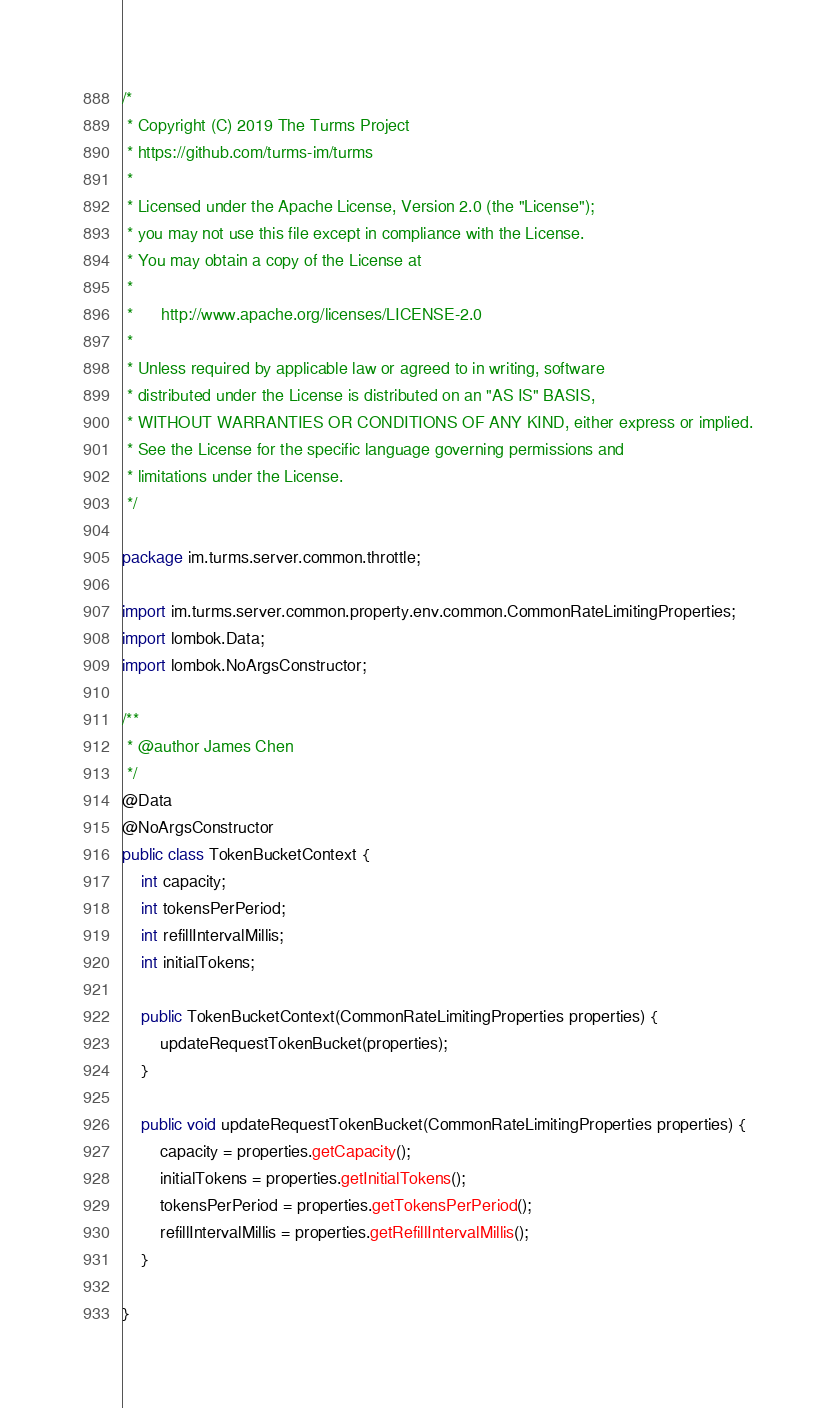Convert code to text. <code><loc_0><loc_0><loc_500><loc_500><_Java_>/*
 * Copyright (C) 2019 The Turms Project
 * https://github.com/turms-im/turms
 *
 * Licensed under the Apache License, Version 2.0 (the "License");
 * you may not use this file except in compliance with the License.
 * You may obtain a copy of the License at
 *
 *      http://www.apache.org/licenses/LICENSE-2.0
 *
 * Unless required by applicable law or agreed to in writing, software
 * distributed under the License is distributed on an "AS IS" BASIS,
 * WITHOUT WARRANTIES OR CONDITIONS OF ANY KIND, either express or implied.
 * See the License for the specific language governing permissions and
 * limitations under the License.
 */

package im.turms.server.common.throttle;

import im.turms.server.common.property.env.common.CommonRateLimitingProperties;
import lombok.Data;
import lombok.NoArgsConstructor;

/**
 * @author James Chen
 */
@Data
@NoArgsConstructor
public class TokenBucketContext {
    int capacity;
    int tokensPerPeriod;
    int refillIntervalMillis;
    int initialTokens;

    public TokenBucketContext(CommonRateLimitingProperties properties) {
        updateRequestTokenBucket(properties);
    }

    public void updateRequestTokenBucket(CommonRateLimitingProperties properties) {
        capacity = properties.getCapacity();
        initialTokens = properties.getInitialTokens();
        tokensPerPeriod = properties.getTokensPerPeriod();
        refillIntervalMillis = properties.getRefillIntervalMillis();
    }

}</code> 